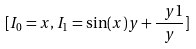Convert formula to latex. <formula><loc_0><loc_0><loc_500><loc_500>[ I _ { 0 } = x , I _ { 1 } = \sin ( x ) y + { \frac { \ y 1 } { y } } ]</formula> 